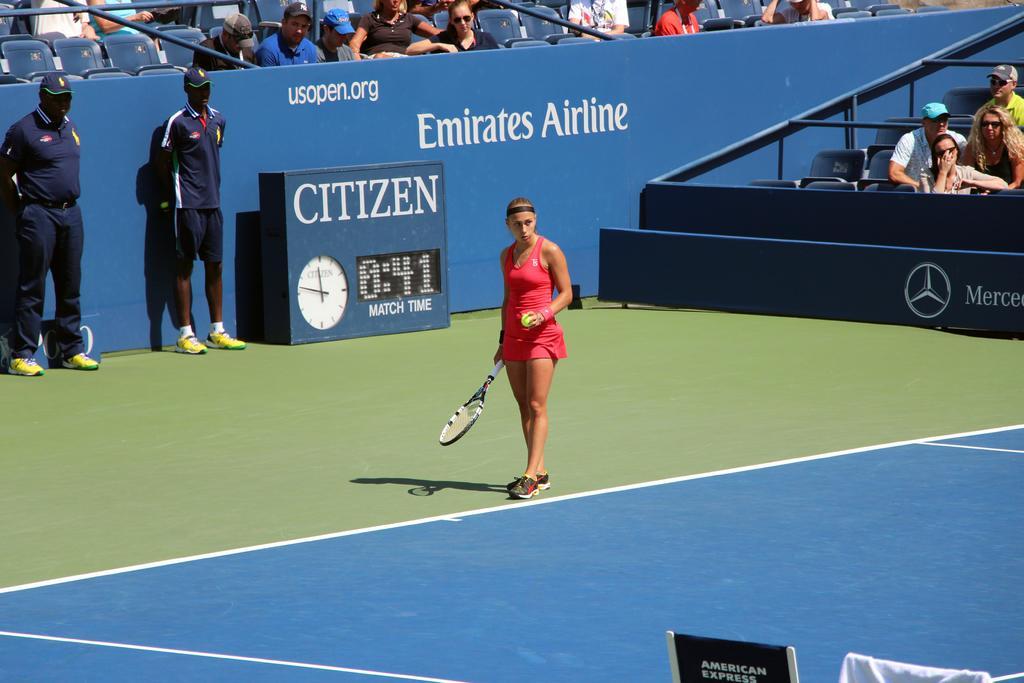Can you describe this image briefly? In this image I can see two men and a woman are standing. I can see she is holding a racket and a ball, here I can see both of them are wearing caps and there I can see a clock. In the background I can see number of people and most of them are wearing caps. 